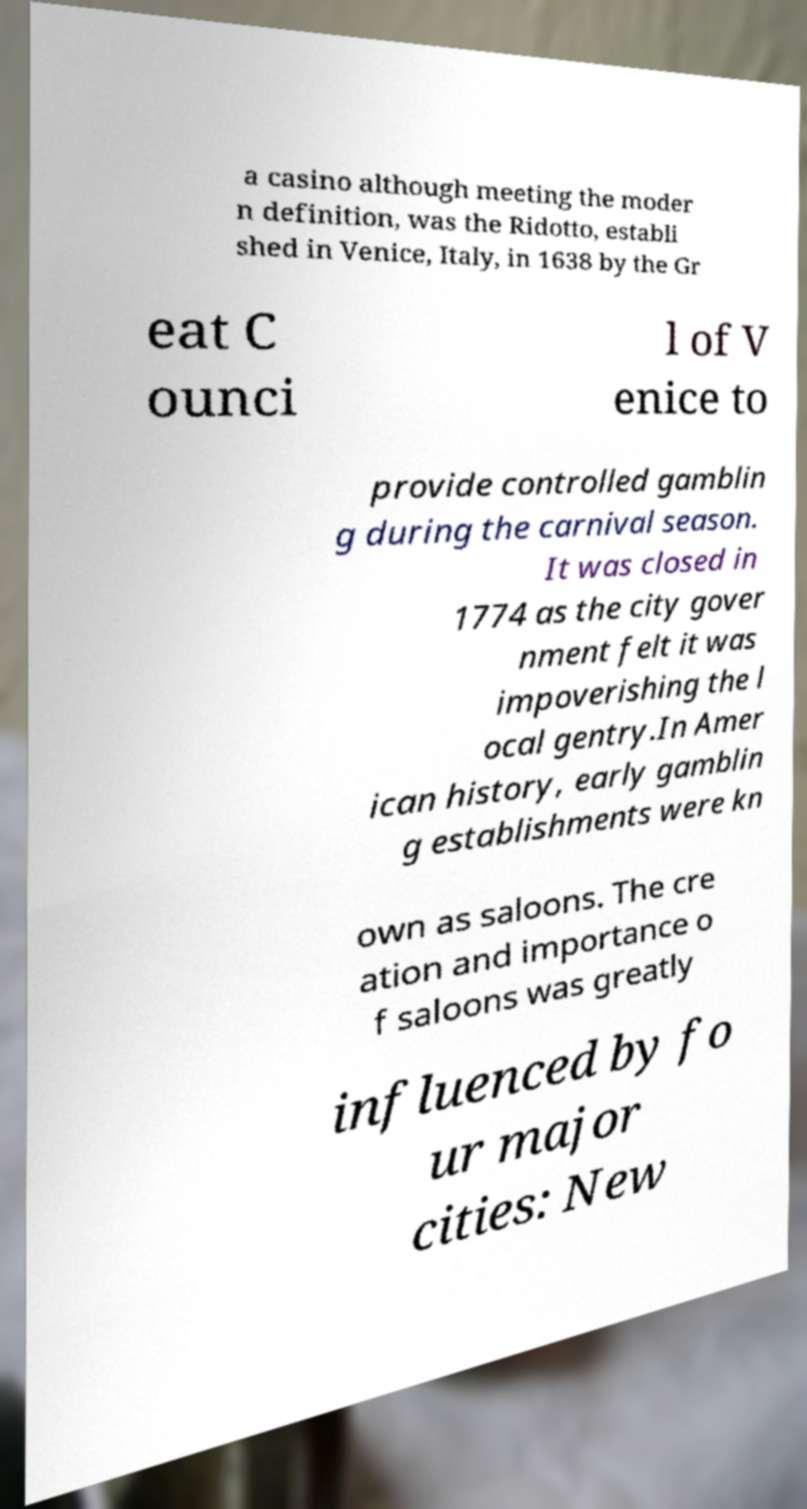Can you read and provide the text displayed in the image?This photo seems to have some interesting text. Can you extract and type it out for me? a casino although meeting the moder n definition, was the Ridotto, establi shed in Venice, Italy, in 1638 by the Gr eat C ounci l of V enice to provide controlled gamblin g during the carnival season. It was closed in 1774 as the city gover nment felt it was impoverishing the l ocal gentry.In Amer ican history, early gamblin g establishments were kn own as saloons. The cre ation and importance o f saloons was greatly influenced by fo ur major cities: New 